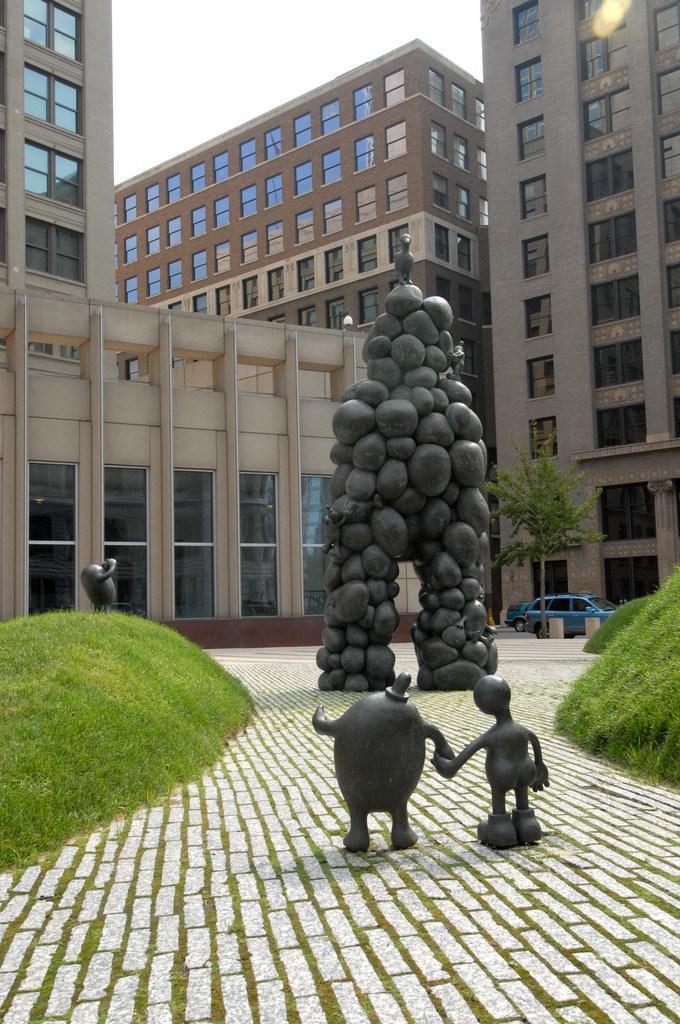Can you describe this image briefly? In this picture there are sculptures in the center of the image and there is greenery on the right and left side of the image and there are skyscrapers in the background area of the image. 